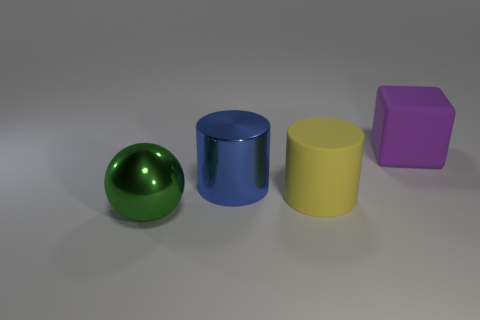Can you describe the shapes and colors of the objects starting from the left? Certainly! Starting from the left, we have a green sphere with a shiny metallic finish, reflecting its surroundings. Next is a deep blue cylinder, also with a high-gloss metallic surface, standing upright. After that is a yellow cylinder, similar in texture to the blue one but a bit shorter, with a matte finish. Finally, on the far right, there's a purple cube with a smooth but matte surface, contrasting in both shape and texture to the cylinders. 